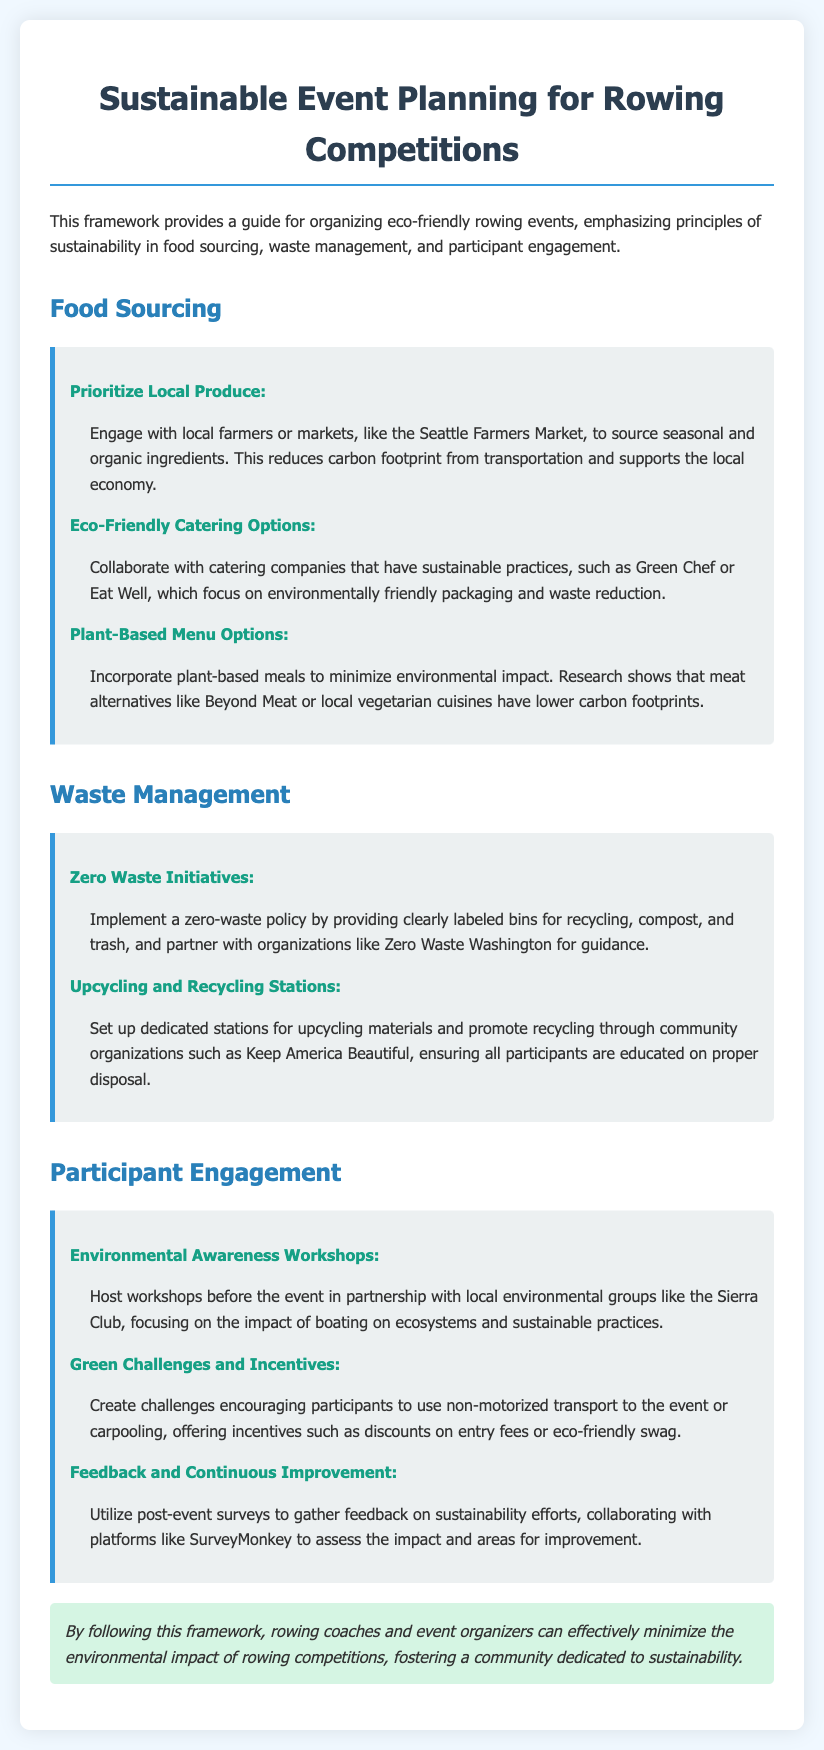What is the title of the manual? The title is prominently displayed as the main heading of the document.
Answer: Sustainable Event Planning for Rowing Competitions What are two eco-friendly catering companies mentioned? The document lists these companies as examples that focus on sustainable practices.
Answer: Green Chef, Eat Well What is one principle to prioritize in food sourcing? The principles for food sourcing are clearly outlined, with a focus on local engagement.
Answer: Local Produce What should be provided for proper waste disposal? The document specifies what needs to be implemented for effective waste management.
Answer: Labeled bins Who can help with environmental awareness workshops? The document provides a suggestion for local partnerships to enhance participant engagement.
Answer: Sierra Club What type of menu options are suggested to minimize environmental impact? There is an emphasis on specific dietary options within the food sourcing section.
Answer: Plant-Based What initiative promotes recycling and upcycling? The document gives guidance on specific actions to promote environmental consciousness among participants.
Answer: Upcycling and Recycling Stations What method is recommended to gather feedback post-event? The document mentions a collaborative platform for evaluating sustainability efforts after the event.
Answer: SurveyMonkey What type of policy can be implemented to manage waste? The document clearly describes a specific approach to managing waste at the event.
Answer: Zero Waste Policy 